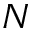<formula> <loc_0><loc_0><loc_500><loc_500>N</formula> 